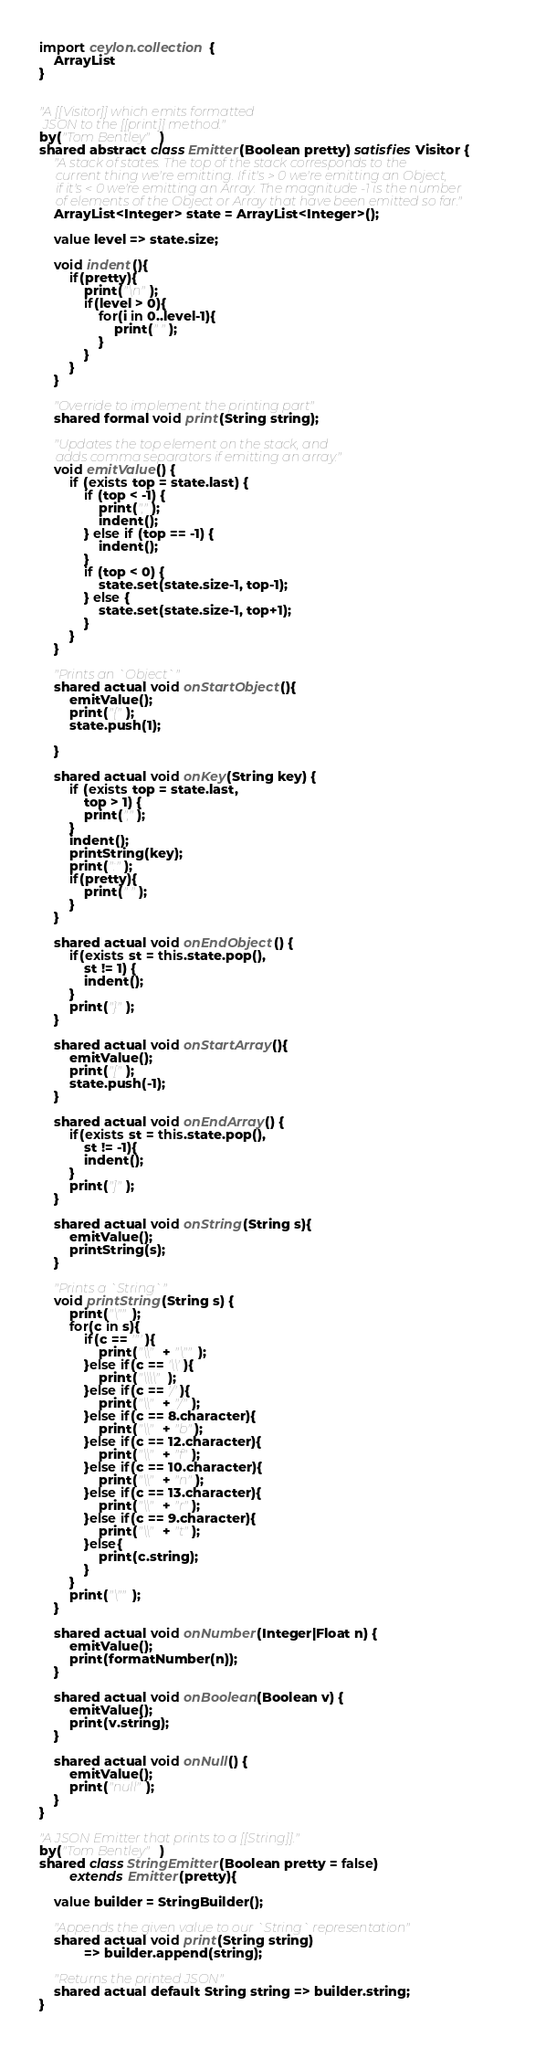Convert code to text. <code><loc_0><loc_0><loc_500><loc_500><_Ceylon_>import ceylon.collection {
    ArrayList
}


"A [[Visitor]] which emits formatted 
 JSON to the [[print]] method."
by("Tom Bentley")
shared abstract class Emitter(Boolean pretty) satisfies Visitor {
    "A stack of states. The top of the stack corresponds to the 
     current thing we're emitting. If it's > 0 we're emitting an Object,
     if it's < 0 we're emitting an Array. The magnitude -1 is the number 
     of elements of the Object or Array that have been emitted so far."
    ArrayList<Integer> state = ArrayList<Integer>();
    
    value level => state.size;
    
    void indent(){
        if(pretty){
            print("\n");
            if(level > 0){
                for(i in 0..level-1){
                    print(" ");
                }
            }
        }
    }
    
    "Override to implement the printing part"
    shared formal void print(String string);
    
    "Updates the top element on the stack, and 
     adds comma separators if emitting an array."
    void emitValue() {
        if (exists top = state.last) {
            if (top < -1) {
                print(",");
                indent();
            } else if (top == -1) {
                indent();
            }
            if (top < 0) {
                state.set(state.size-1, top-1);
            } else {
                state.set(state.size-1, top+1);
            }
        }
    }
    
    "Prints an `Object`"
    shared actual void onStartObject(){
        emitValue();
        print("{");
        state.push(1);
        
    }
    
    shared actual void onKey(String key) {
        if (exists top = state.last,
            top > 1) {
            print(",");
        }
        indent();
        printString(key);
        print(":");
        if(pretty){
            print(" ");
        }
    }
    
    shared actual void onEndObject() {
        if(exists st = this.state.pop(), 
            st != 1) {
            indent();
        }
        print("}");
    }
    
    shared actual void onStartArray(){
        emitValue();
        print("[");
        state.push(-1);
    }
    
    shared actual void onEndArray() {
        if(exists st = this.state.pop(), 
            st != -1){
            indent();
        }
        print("]");
    }
    
    shared actual void onString(String s){
        emitValue();
        printString(s);
    }
    
    "Prints a `String`"
    void printString(String s) {
        print("\"");
        for(c in s){
            if(c == '"'){
                print("\\" + "\"");
            }else if(c == '\\'){
                print("\\\\");
            }else if(c == '/'){
                print("\\" + "/");
            }else if(c == 8.character){
                print("\\" + "b");
            }else if(c == 12.character){
                print("\\" + "f");
            }else if(c == 10.character){
                print("\\" + "n");
            }else if(c == 13.character){
                print("\\" + "r");
            }else if(c == 9.character){
                print("\\" + "t");
            }else{
                print(c.string);
            }
        }
        print("\"");
    }
    
    shared actual void onNumber(Integer|Float n) {
        emitValue();
        print(formatNumber(n));
    }
    
    shared actual void onBoolean(Boolean v) {
        emitValue();
        print(v.string);
    }
    
    shared actual void onNull() {
        emitValue();
        print("null");
    }
}

"A JSON Emitter that prints to a [[String]]."
by("Tom Bentley")
shared class StringEmitter(Boolean pretty = false) 
        extends Emitter(pretty){
    
    value builder = StringBuilder();
    
    "Appends the given value to our `String` representation"
    shared actual void print(String string)
            => builder.append(string);
    
    "Returns the printed JSON"
    shared actual default String string => builder.string;
}
</code> 